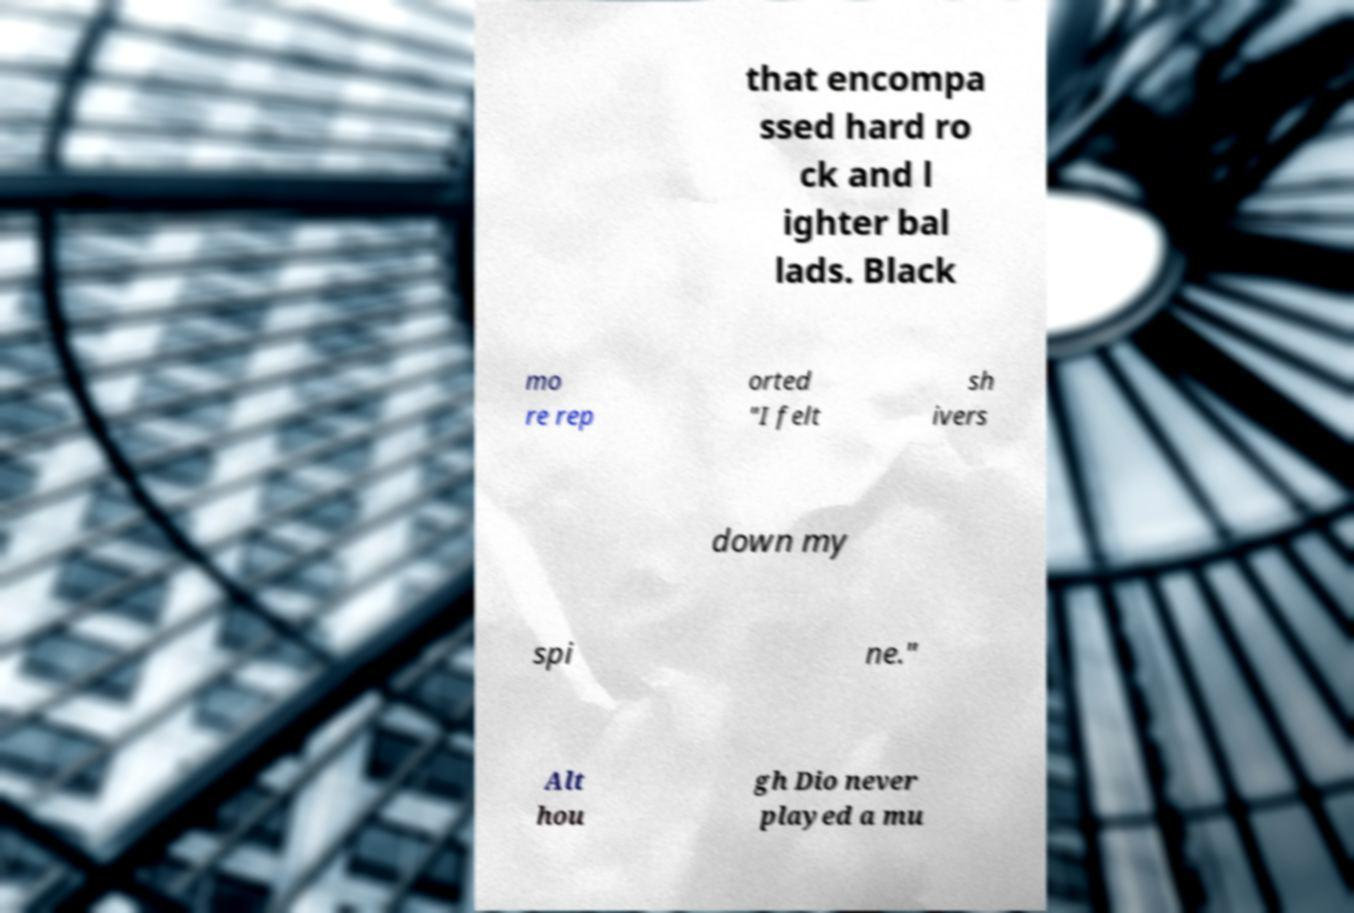I need the written content from this picture converted into text. Can you do that? that encompa ssed hard ro ck and l ighter bal lads. Black mo re rep orted "I felt sh ivers down my spi ne." Alt hou gh Dio never played a mu 